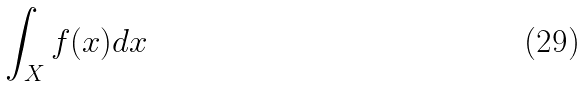Convert formula to latex. <formula><loc_0><loc_0><loc_500><loc_500>\int _ { X } f ( x ) d x</formula> 